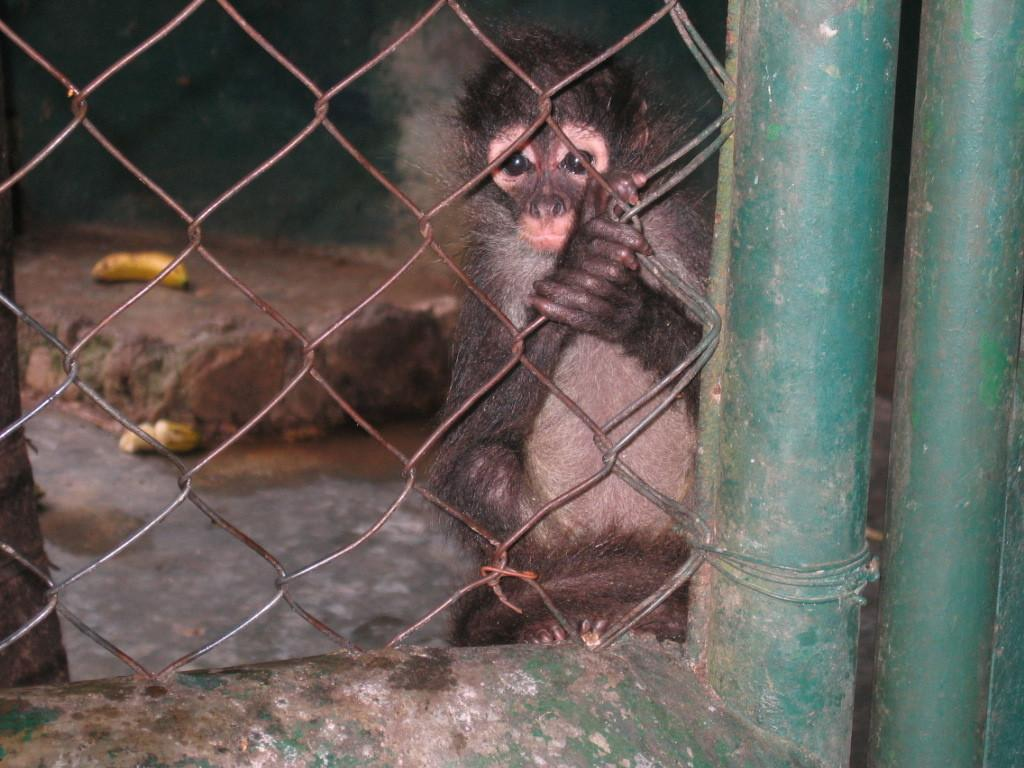What type of animal can be seen in the image? There is an animal in the image that resembles a monkey. What is the monkey-like animal doing in the image? The monkey-like animal is holding a fence. How is the fence connected to the wall in the image? The fence is attached to a wall. What other object can be seen in the image? There is an iron pole in the image. What can be found on the floor in the background of the image? In the background, there are two bananas on the floor. Is there a loaf of bread visible in the image? No, there is no loaf of bread present in the image. Can you tell me how many coaches are in the image? There are no coaches present in the image. 